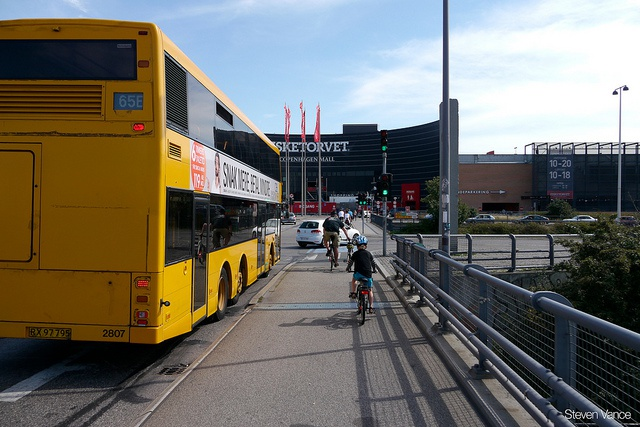Describe the objects in this image and their specific colors. I can see bus in lightblue, maroon, black, and orange tones, people in lightblue, black, gray, darkblue, and darkgray tones, car in lightblue, black, lightgray, and gray tones, people in lightblue, black, gray, maroon, and darkgray tones, and bicycle in lightblue, black, gray, and maroon tones in this image. 